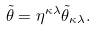Convert formula to latex. <formula><loc_0><loc_0><loc_500><loc_500>\tilde { \theta } = \eta ^ { \kappa \lambda } \tilde { \theta } _ { \kappa \lambda } .</formula> 